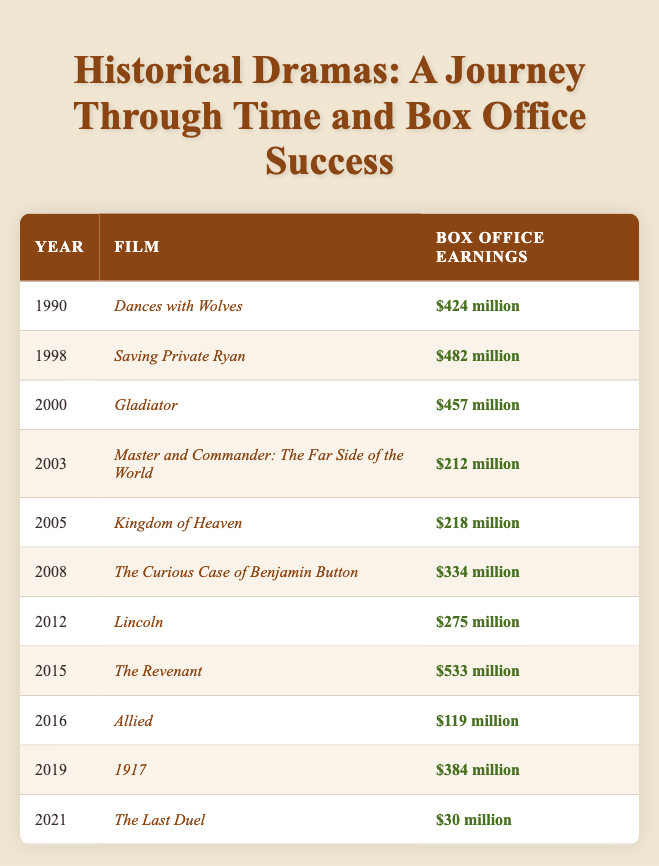What was the highest box office earning film from the table? The film with the highest box office earnings listed in the table is "The Revenant," which made $533 million.
Answer: $533 million Which film earned less than $100 million? According to the table, "The Last Duel" is the only film that earned less than $100 million, specifically $30 million.
Answer: Yes What is the difference in box office earnings between “Saving Private Ryan” and “Master and Commander: The Far Side of the World”? "Saving Private Ryan" earned $482 million, while "Master and Commander" earned $212 million. The difference is $482 million - $212 million = $270 million.
Answer: $270 million What is the average box office earning of the films from 2000 to 2021? The films from 2000 to 2021 are: Gladiator ($457 million), Master and Commander ($212 million), Kingdom of Heaven ($218 million), The Curious Case of Benjamin Button ($334 million), Lincoln ($275 million), The Revenant ($533 million), Allied ($119 million), 1917 ($384 million), and The Last Duel ($30 million). We sum these values: (457 + 212 + 218 + 334 + 275 + 533 + 119 + 384 + 30) = $2,162 million. There are 9 films in this period, so the average is $2,162 million / 9 ≈ $240.22 million.
Answer: Approximately $240.22 million Was the box office earning of "Dances with Wolves" greater than that of "Lincoln"? "Dances with Wolves" earned $424 million, while "Lincoln" earned $275 million. Since $424 million is greater than $275 million, the statement is true.
Answer: Yes How many films made over $400 million? The films that made over $400 million are "Dances with Wolves" ($424 million), "Saving Private Ryan" ($482 million), "Gladiator" ($457 million), and "The Revenant" ($533 million). Counting these films gives a total of 4.
Answer: 4 What is the total box office earning of all films listed from the year 2005 onward? The films from 2005 onward and their earnings are: Kingdom of Heaven ($218 million), The Curious Case of Benjamin Button ($334 million), Lincoln ($275 million), The Revenant ($533 million), Allied ($119 million), 1917 ($384 million), and The Last Duel ($30 million). The total is: (218 + 334 + 275 + 533 + 119 + 384 + 30) = $1,893 million.
Answer: $1,893 million Which year had the lowest box office earnings for a historical film? The year with the lowest box office earnings is 2021, with "The Last Duel" earning only $30 million.
Answer: 2021 What was the box office earning of “1917,” and how does it compare to “Kingdom of Heaven”? "1917" earned $384 million, while "Kingdom of Heaven" earned $218 million. The comparison shows that "1917" earned $166 million more than "Kingdom of Heaven."
Answer: $166 million more Which film released in 2008 made how much at the box office? The film released in 2008 is "The Curious Case of Benjamin Button," which made $334 million at the box office.
Answer: $334 million If we exclude "The Last Duel," what is the new average box office earnings of the remaining films? Total earnings excluding "The Last Duel": (424 + 482 + 457 + 212 + 218 + 334 + 275 + 533 + 119 + 384) = $2,464 million with 10 - 1 = 9 films remaining. The new average is $2,464 million / 9 ≈ $274.89 million.
Answer: Approximately $274.89 million 